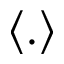<formula> <loc_0><loc_0><loc_500><loc_500>\langle . \rangle</formula> 